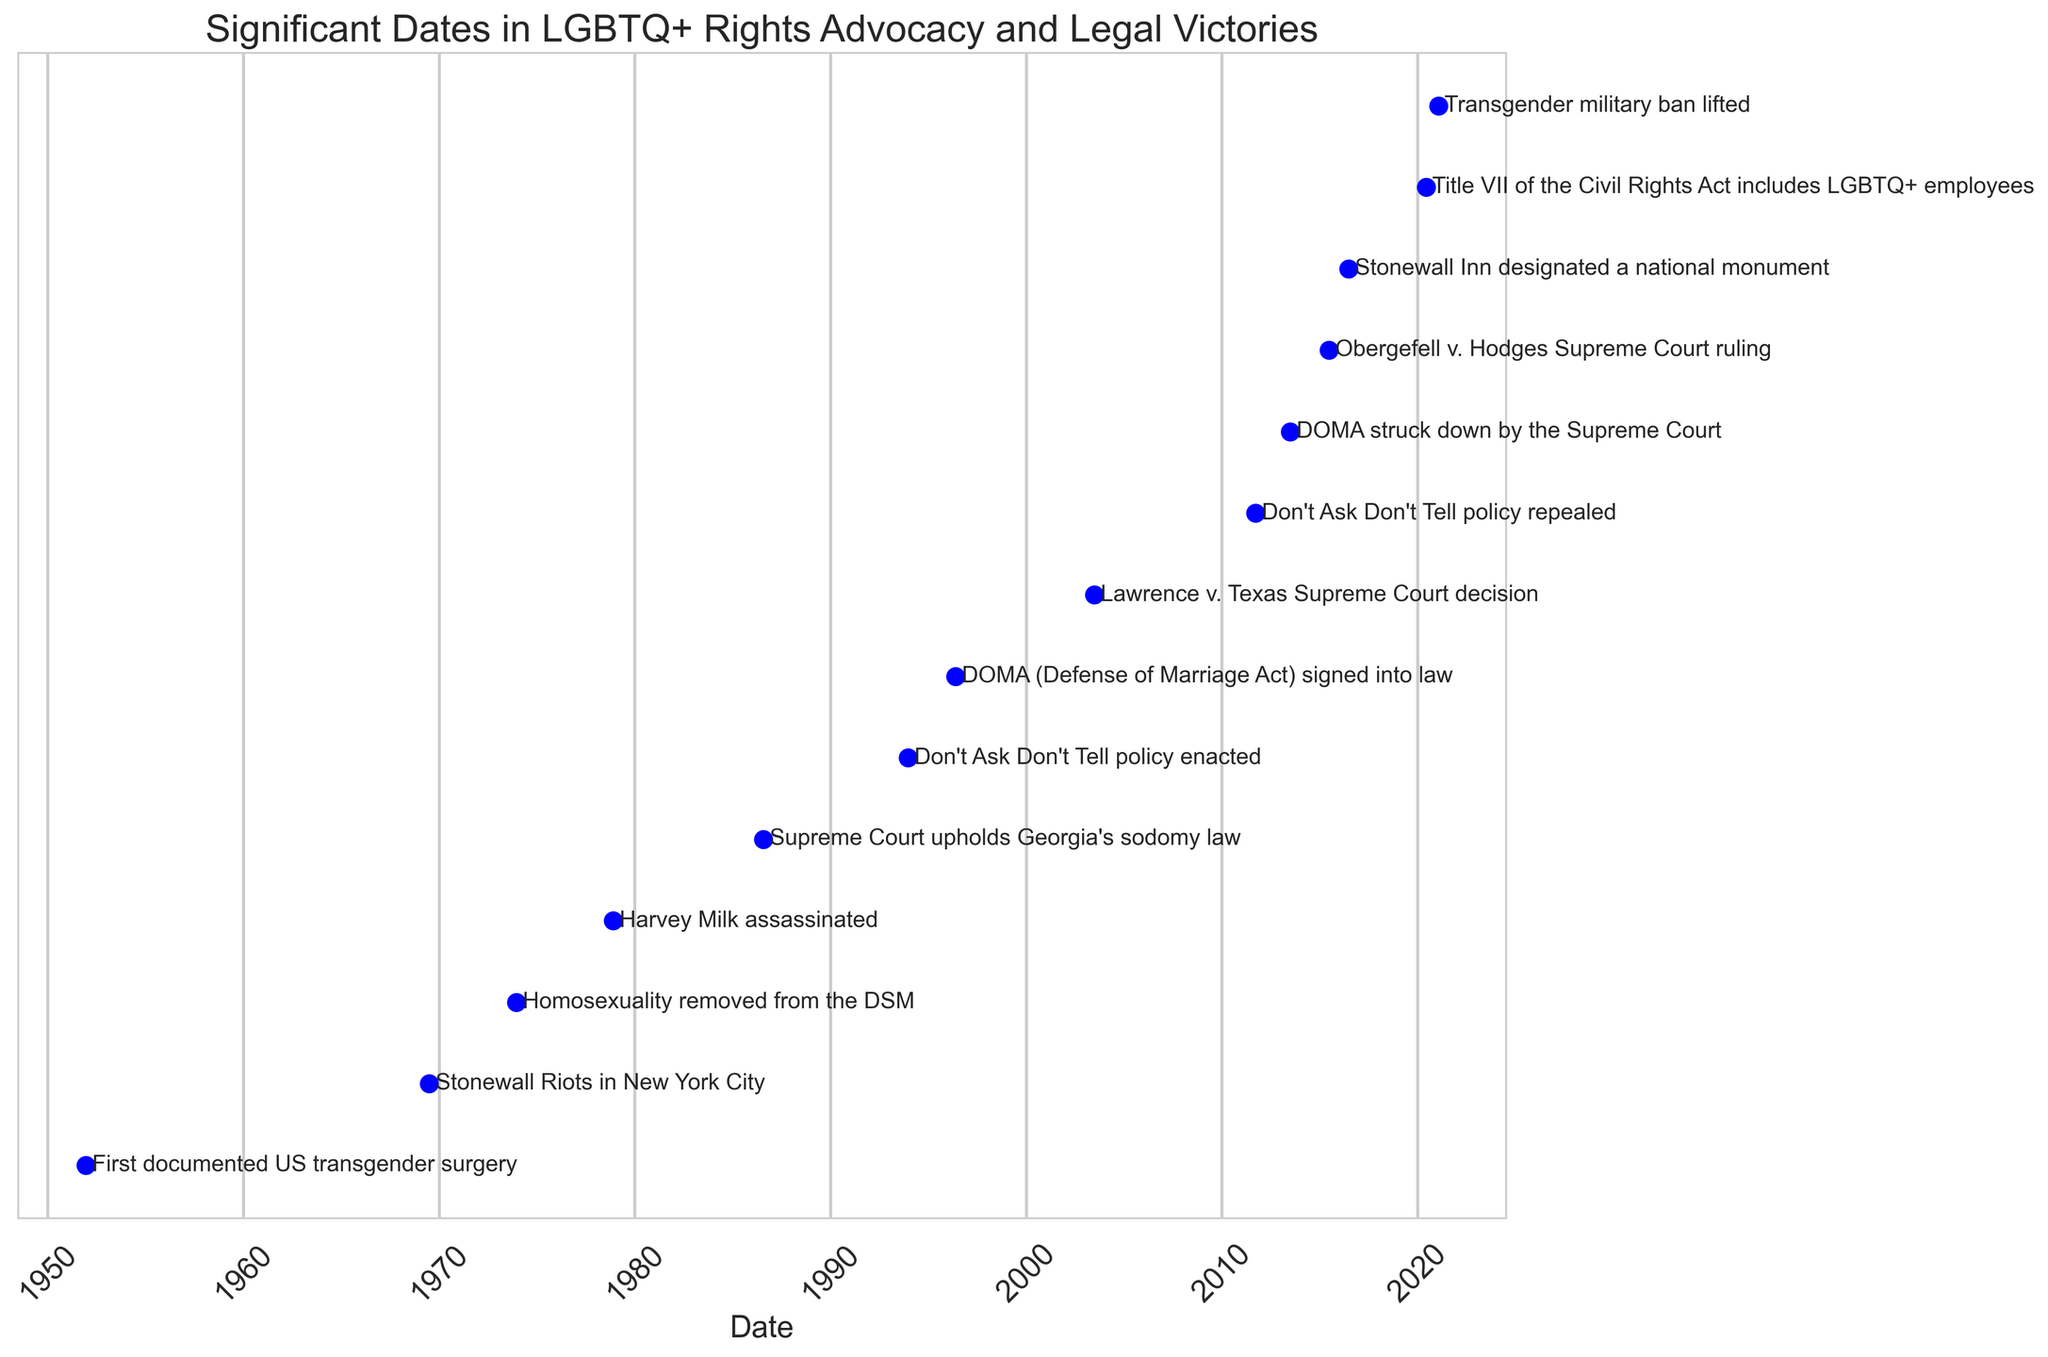When did the Stonewall Riots occur? The figure shows the Stonewall Riots event next to the date 1969-06-28.
Answer: 1969-06-28 How many years apart are the removal of homosexuality from the DSM and the Obergefell v. Hodges ruling? The removal from the DSM happened on 1973-12-15 and the Obergefell v. Hodges ruling on 2015-06-26. Calculate the difference between these two dates.
Answer: 41 years, 6 months, 11 days Which event happened first, the signing of DOMA or the enactment of Don't Ask Don't Tell? The figure shows the Don't Ask Don't Tell policy enacted on 1993-12-21 and DOMA signed into law on 1996-05-20. The Don't Ask Don't Tell policy was enacted first.
Answer: Don't Ask Don't Tell policy enactment What is the median date of these listed events? To find the median, list all the dates in order and find the middle value. Since there are 14 events, the median date will be the average of the 7th and 8th dates in the sorted list. The dates are: 1951-12-15, 1969-06-28, 1973-12-15, 1978-11-27, 1986-07-31, 1993-12-21, 1996-05-20, 2003-06-26, 2011-09-20, 2013-06-26, 2015-06-26, 2016-06-24, 2020-06-15, and 2021-01-25. The 7th and 8th dates are 1996-05-20 and 2003-06-26.
Answer: May 20, 1996, and June 26, 2003 Which two events have the shortest time interval between them? Calculate the difference between each pair of consecutive dates. The shortest interval is between the Supreme Court ruling on DOMA (2013-06-26) and the Obergefell v. Hodges ruling (2015-06-26), which is exactly 2 years.
Answer: DOMA ruling and Obergefell v. Hodges ruling 